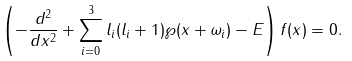Convert formula to latex. <formula><loc_0><loc_0><loc_500><loc_500>\left ( - \frac { d ^ { 2 } } { d x ^ { 2 } } + \sum _ { i = 0 } ^ { 3 } l _ { i } ( l _ { i } + 1 ) \wp ( x + \omega _ { i } ) - E \right ) f ( x ) = 0 .</formula> 